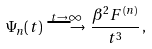<formula> <loc_0><loc_0><loc_500><loc_500>\Psi _ { n } ( t ) \, \stackrel { t \to \infty } { \longrightarrow } \, \frac { \beta ^ { 2 } F ^ { ( n ) } } { t ^ { 3 } } \, ,</formula> 